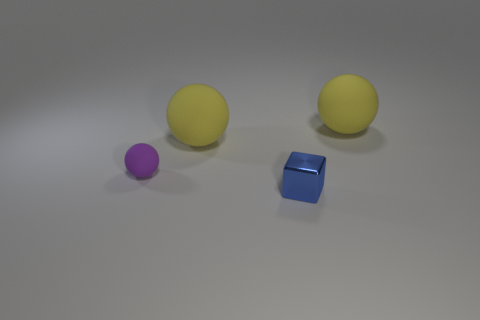What is the shape of the object that is on the left side of the big rubber object left of the large yellow rubber thing right of the metal object?
Provide a short and direct response. Sphere. Is the number of cubes greater than the number of large gray cylinders?
Keep it short and to the point. Yes. Is the purple ball made of the same material as the block?
Offer a very short reply. No. Are there more small rubber spheres that are in front of the small purple thing than big brown shiny cylinders?
Your response must be concise. No. What is the yellow ball right of the large yellow rubber sphere that is to the left of the big yellow thing that is right of the metal cube made of?
Your answer should be compact. Rubber. What number of things are tiny purple metal balls or tiny objects on the left side of the small blue shiny block?
Give a very brief answer. 1. Are there more yellow balls behind the cube than purple things that are in front of the purple sphere?
Ensure brevity in your answer.  Yes. What number of things are either tiny rubber spheres or big yellow matte objects?
Ensure brevity in your answer.  3. There is a rubber sphere that is right of the block; does it have the same size as the metallic cube?
Your answer should be very brief. No. How many other things are the same size as the blue block?
Keep it short and to the point. 1. 